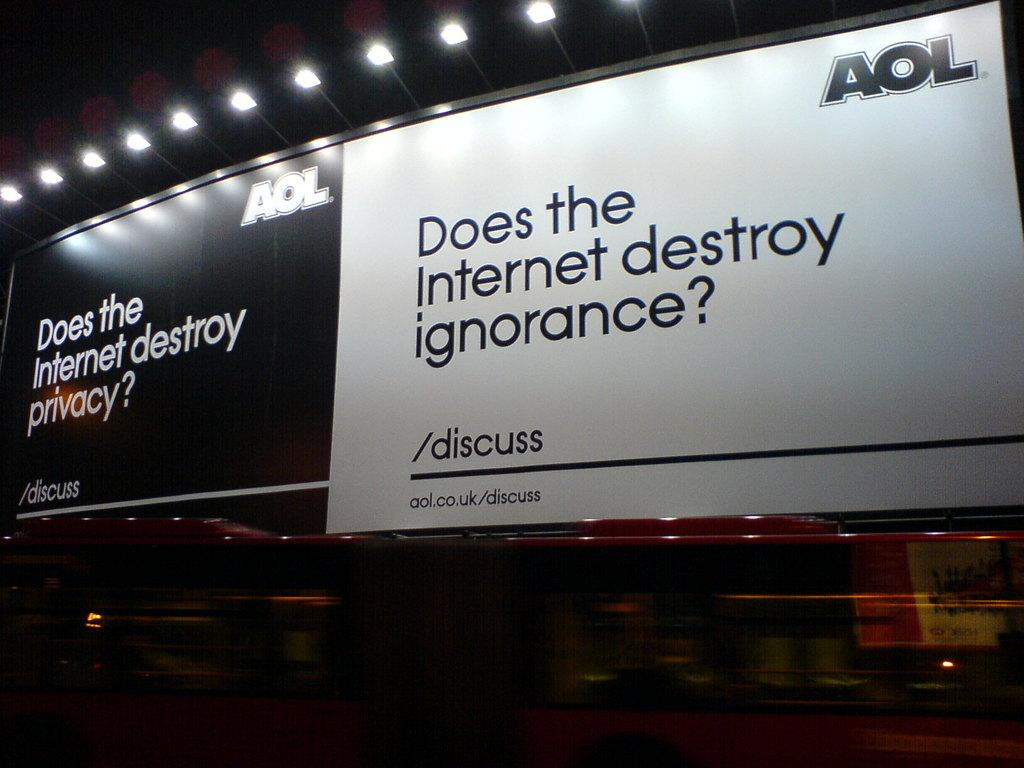<image>
Give a short and clear explanation of the subsequent image. An AOL sign asks if the internet destroys ignorance. 